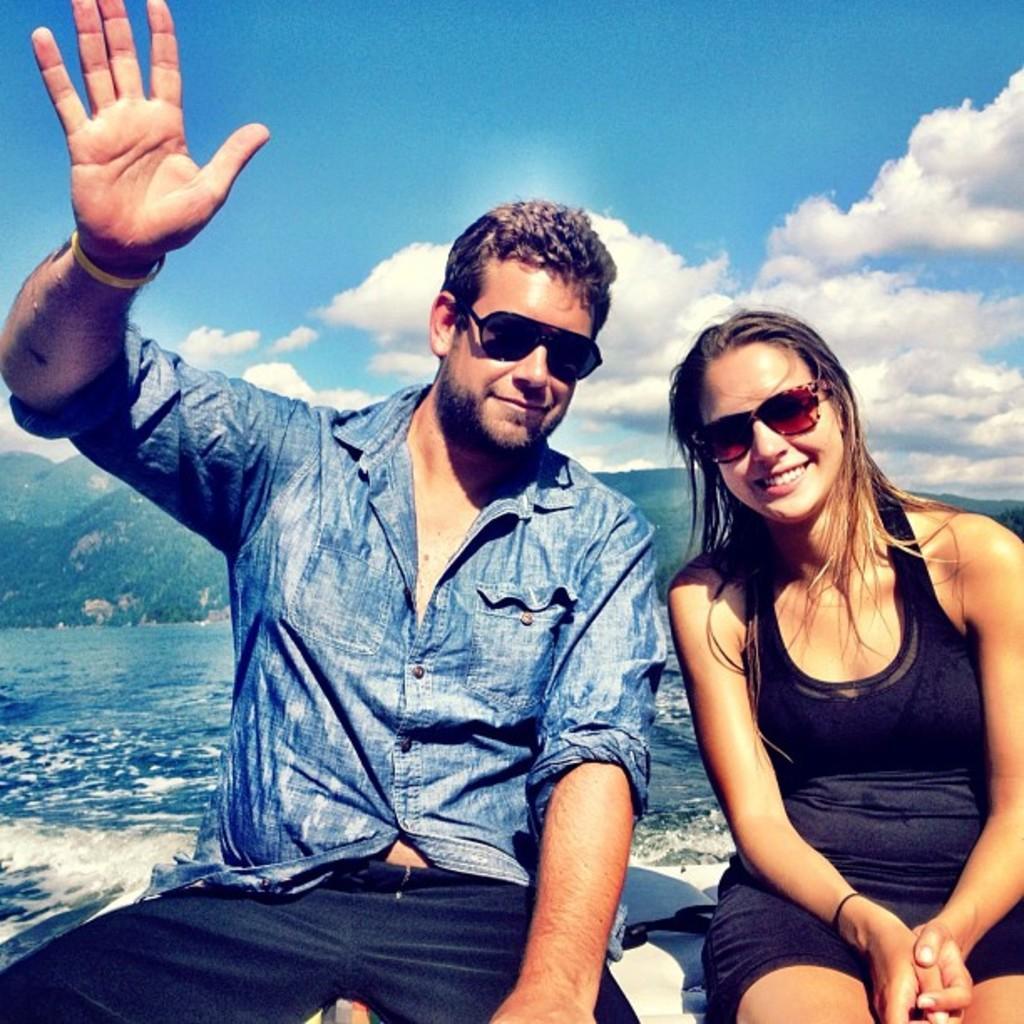Could you give a brief overview of what you see in this image? This picture is clicked outside. On the right corner we can see a woman wearing black color dress, smiling and sitting and we can see a man wearing shirt, smiling and sitting. In the background we can see the sky with the clouds and we can see a water body, chills and some other objects. 